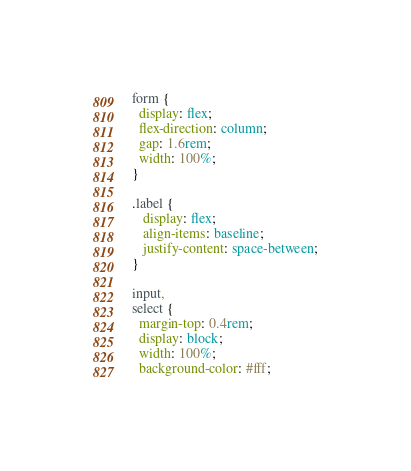<code> <loc_0><loc_0><loc_500><loc_500><_CSS_>form {
  display: flex;
  flex-direction: column;
  gap: 1.6rem;
  width: 100%;
}

.label {
   display: flex;
   align-items: baseline;
   justify-content: space-between;
}

input,
select {
  margin-top: 0.4rem;
  display: block;
  width: 100%;
  background-color: #fff;</code> 